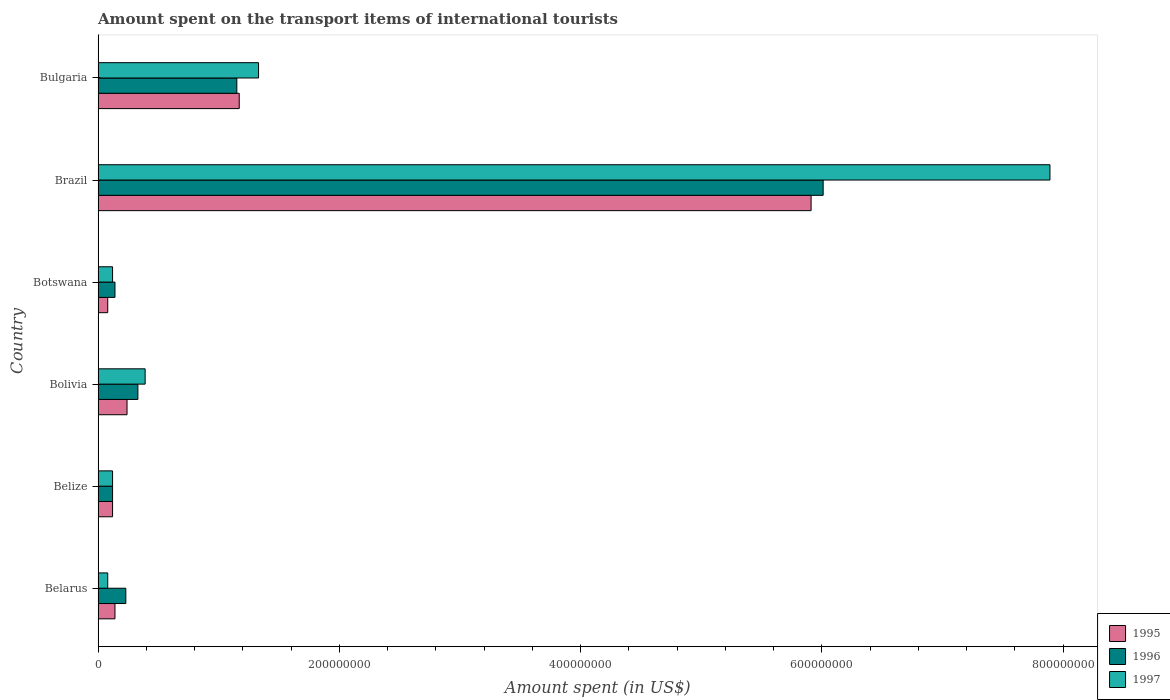How many groups of bars are there?
Your response must be concise. 6. Are the number of bars on each tick of the Y-axis equal?
Provide a short and direct response. Yes. In how many cases, is the number of bars for a given country not equal to the number of legend labels?
Offer a very short reply. 0. What is the amount spent on the transport items of international tourists in 1995 in Botswana?
Provide a succinct answer. 8.00e+06. Across all countries, what is the maximum amount spent on the transport items of international tourists in 1996?
Offer a very short reply. 6.01e+08. In which country was the amount spent on the transport items of international tourists in 1997 maximum?
Offer a terse response. Brazil. In which country was the amount spent on the transport items of international tourists in 1995 minimum?
Offer a very short reply. Botswana. What is the total amount spent on the transport items of international tourists in 1997 in the graph?
Ensure brevity in your answer.  9.93e+08. What is the difference between the amount spent on the transport items of international tourists in 1995 in Belarus and that in Bolivia?
Keep it short and to the point. -1.00e+07. What is the difference between the amount spent on the transport items of international tourists in 1995 in Bulgaria and the amount spent on the transport items of international tourists in 1996 in Botswana?
Ensure brevity in your answer.  1.03e+08. What is the average amount spent on the transport items of international tourists in 1995 per country?
Ensure brevity in your answer.  1.28e+08. What is the difference between the amount spent on the transport items of international tourists in 1997 and amount spent on the transport items of international tourists in 1995 in Bolivia?
Give a very brief answer. 1.50e+07. In how many countries, is the amount spent on the transport items of international tourists in 1995 greater than 320000000 US$?
Make the answer very short. 1. What is the ratio of the amount spent on the transport items of international tourists in 1997 in Botswana to that in Brazil?
Provide a short and direct response. 0.02. What is the difference between the highest and the second highest amount spent on the transport items of international tourists in 1997?
Your response must be concise. 6.56e+08. What is the difference between the highest and the lowest amount spent on the transport items of international tourists in 1995?
Give a very brief answer. 5.83e+08. In how many countries, is the amount spent on the transport items of international tourists in 1997 greater than the average amount spent on the transport items of international tourists in 1997 taken over all countries?
Ensure brevity in your answer.  1. What does the 2nd bar from the bottom in Bulgaria represents?
Give a very brief answer. 1996. Is it the case that in every country, the sum of the amount spent on the transport items of international tourists in 1995 and amount spent on the transport items of international tourists in 1996 is greater than the amount spent on the transport items of international tourists in 1997?
Offer a very short reply. Yes. How many bars are there?
Your answer should be very brief. 18. How many countries are there in the graph?
Make the answer very short. 6. Are the values on the major ticks of X-axis written in scientific E-notation?
Your answer should be very brief. No. Does the graph contain grids?
Ensure brevity in your answer.  No. How many legend labels are there?
Your response must be concise. 3. How are the legend labels stacked?
Your answer should be compact. Vertical. What is the title of the graph?
Ensure brevity in your answer.  Amount spent on the transport items of international tourists. What is the label or title of the X-axis?
Provide a succinct answer. Amount spent (in US$). What is the Amount spent (in US$) in 1995 in Belarus?
Offer a terse response. 1.40e+07. What is the Amount spent (in US$) of 1996 in Belarus?
Offer a very short reply. 2.30e+07. What is the Amount spent (in US$) in 1997 in Belize?
Provide a succinct answer. 1.20e+07. What is the Amount spent (in US$) in 1995 in Bolivia?
Your response must be concise. 2.40e+07. What is the Amount spent (in US$) in 1996 in Bolivia?
Give a very brief answer. 3.30e+07. What is the Amount spent (in US$) in 1997 in Bolivia?
Ensure brevity in your answer.  3.90e+07. What is the Amount spent (in US$) in 1995 in Botswana?
Provide a succinct answer. 8.00e+06. What is the Amount spent (in US$) in 1996 in Botswana?
Your response must be concise. 1.40e+07. What is the Amount spent (in US$) in 1995 in Brazil?
Make the answer very short. 5.91e+08. What is the Amount spent (in US$) of 1996 in Brazil?
Provide a succinct answer. 6.01e+08. What is the Amount spent (in US$) in 1997 in Brazil?
Offer a terse response. 7.89e+08. What is the Amount spent (in US$) in 1995 in Bulgaria?
Provide a short and direct response. 1.17e+08. What is the Amount spent (in US$) in 1996 in Bulgaria?
Provide a short and direct response. 1.15e+08. What is the Amount spent (in US$) of 1997 in Bulgaria?
Your answer should be compact. 1.33e+08. Across all countries, what is the maximum Amount spent (in US$) in 1995?
Ensure brevity in your answer.  5.91e+08. Across all countries, what is the maximum Amount spent (in US$) of 1996?
Provide a succinct answer. 6.01e+08. Across all countries, what is the maximum Amount spent (in US$) in 1997?
Offer a very short reply. 7.89e+08. Across all countries, what is the minimum Amount spent (in US$) of 1996?
Keep it short and to the point. 1.20e+07. Across all countries, what is the minimum Amount spent (in US$) of 1997?
Your answer should be compact. 8.00e+06. What is the total Amount spent (in US$) in 1995 in the graph?
Your answer should be very brief. 7.66e+08. What is the total Amount spent (in US$) of 1996 in the graph?
Ensure brevity in your answer.  7.98e+08. What is the total Amount spent (in US$) in 1997 in the graph?
Make the answer very short. 9.93e+08. What is the difference between the Amount spent (in US$) in 1996 in Belarus and that in Belize?
Your response must be concise. 1.10e+07. What is the difference between the Amount spent (in US$) of 1995 in Belarus and that in Bolivia?
Your answer should be compact. -1.00e+07. What is the difference between the Amount spent (in US$) of 1996 in Belarus and that in Bolivia?
Give a very brief answer. -1.00e+07. What is the difference between the Amount spent (in US$) of 1997 in Belarus and that in Bolivia?
Provide a short and direct response. -3.10e+07. What is the difference between the Amount spent (in US$) of 1996 in Belarus and that in Botswana?
Your response must be concise. 9.00e+06. What is the difference between the Amount spent (in US$) in 1997 in Belarus and that in Botswana?
Provide a succinct answer. -4.00e+06. What is the difference between the Amount spent (in US$) in 1995 in Belarus and that in Brazil?
Offer a very short reply. -5.77e+08. What is the difference between the Amount spent (in US$) of 1996 in Belarus and that in Brazil?
Keep it short and to the point. -5.78e+08. What is the difference between the Amount spent (in US$) in 1997 in Belarus and that in Brazil?
Offer a very short reply. -7.81e+08. What is the difference between the Amount spent (in US$) in 1995 in Belarus and that in Bulgaria?
Your answer should be compact. -1.03e+08. What is the difference between the Amount spent (in US$) in 1996 in Belarus and that in Bulgaria?
Make the answer very short. -9.20e+07. What is the difference between the Amount spent (in US$) of 1997 in Belarus and that in Bulgaria?
Make the answer very short. -1.25e+08. What is the difference between the Amount spent (in US$) of 1995 in Belize and that in Bolivia?
Provide a succinct answer. -1.20e+07. What is the difference between the Amount spent (in US$) of 1996 in Belize and that in Bolivia?
Offer a terse response. -2.10e+07. What is the difference between the Amount spent (in US$) in 1997 in Belize and that in Bolivia?
Give a very brief answer. -2.70e+07. What is the difference between the Amount spent (in US$) in 1995 in Belize and that in Brazil?
Keep it short and to the point. -5.79e+08. What is the difference between the Amount spent (in US$) in 1996 in Belize and that in Brazil?
Your answer should be very brief. -5.89e+08. What is the difference between the Amount spent (in US$) in 1997 in Belize and that in Brazil?
Ensure brevity in your answer.  -7.77e+08. What is the difference between the Amount spent (in US$) in 1995 in Belize and that in Bulgaria?
Provide a succinct answer. -1.05e+08. What is the difference between the Amount spent (in US$) in 1996 in Belize and that in Bulgaria?
Make the answer very short. -1.03e+08. What is the difference between the Amount spent (in US$) in 1997 in Belize and that in Bulgaria?
Your response must be concise. -1.21e+08. What is the difference between the Amount spent (in US$) in 1995 in Bolivia and that in Botswana?
Ensure brevity in your answer.  1.60e+07. What is the difference between the Amount spent (in US$) in 1996 in Bolivia and that in Botswana?
Make the answer very short. 1.90e+07. What is the difference between the Amount spent (in US$) in 1997 in Bolivia and that in Botswana?
Keep it short and to the point. 2.70e+07. What is the difference between the Amount spent (in US$) in 1995 in Bolivia and that in Brazil?
Give a very brief answer. -5.67e+08. What is the difference between the Amount spent (in US$) in 1996 in Bolivia and that in Brazil?
Offer a terse response. -5.68e+08. What is the difference between the Amount spent (in US$) of 1997 in Bolivia and that in Brazil?
Provide a short and direct response. -7.50e+08. What is the difference between the Amount spent (in US$) of 1995 in Bolivia and that in Bulgaria?
Offer a very short reply. -9.30e+07. What is the difference between the Amount spent (in US$) in 1996 in Bolivia and that in Bulgaria?
Give a very brief answer. -8.20e+07. What is the difference between the Amount spent (in US$) of 1997 in Bolivia and that in Bulgaria?
Provide a short and direct response. -9.40e+07. What is the difference between the Amount spent (in US$) in 1995 in Botswana and that in Brazil?
Provide a succinct answer. -5.83e+08. What is the difference between the Amount spent (in US$) of 1996 in Botswana and that in Brazil?
Make the answer very short. -5.87e+08. What is the difference between the Amount spent (in US$) of 1997 in Botswana and that in Brazil?
Provide a succinct answer. -7.77e+08. What is the difference between the Amount spent (in US$) of 1995 in Botswana and that in Bulgaria?
Give a very brief answer. -1.09e+08. What is the difference between the Amount spent (in US$) in 1996 in Botswana and that in Bulgaria?
Offer a terse response. -1.01e+08. What is the difference between the Amount spent (in US$) in 1997 in Botswana and that in Bulgaria?
Ensure brevity in your answer.  -1.21e+08. What is the difference between the Amount spent (in US$) of 1995 in Brazil and that in Bulgaria?
Offer a very short reply. 4.74e+08. What is the difference between the Amount spent (in US$) in 1996 in Brazil and that in Bulgaria?
Your response must be concise. 4.86e+08. What is the difference between the Amount spent (in US$) of 1997 in Brazil and that in Bulgaria?
Your answer should be compact. 6.56e+08. What is the difference between the Amount spent (in US$) in 1996 in Belarus and the Amount spent (in US$) in 1997 in Belize?
Offer a very short reply. 1.10e+07. What is the difference between the Amount spent (in US$) in 1995 in Belarus and the Amount spent (in US$) in 1996 in Bolivia?
Offer a terse response. -1.90e+07. What is the difference between the Amount spent (in US$) in 1995 in Belarus and the Amount spent (in US$) in 1997 in Bolivia?
Make the answer very short. -2.50e+07. What is the difference between the Amount spent (in US$) in 1996 in Belarus and the Amount spent (in US$) in 1997 in Bolivia?
Your answer should be compact. -1.60e+07. What is the difference between the Amount spent (in US$) of 1995 in Belarus and the Amount spent (in US$) of 1996 in Botswana?
Provide a short and direct response. 0. What is the difference between the Amount spent (in US$) of 1995 in Belarus and the Amount spent (in US$) of 1997 in Botswana?
Give a very brief answer. 2.00e+06. What is the difference between the Amount spent (in US$) in 1996 in Belarus and the Amount spent (in US$) in 1997 in Botswana?
Keep it short and to the point. 1.10e+07. What is the difference between the Amount spent (in US$) of 1995 in Belarus and the Amount spent (in US$) of 1996 in Brazil?
Give a very brief answer. -5.87e+08. What is the difference between the Amount spent (in US$) in 1995 in Belarus and the Amount spent (in US$) in 1997 in Brazil?
Offer a terse response. -7.75e+08. What is the difference between the Amount spent (in US$) in 1996 in Belarus and the Amount spent (in US$) in 1997 in Brazil?
Your answer should be very brief. -7.66e+08. What is the difference between the Amount spent (in US$) in 1995 in Belarus and the Amount spent (in US$) in 1996 in Bulgaria?
Your answer should be compact. -1.01e+08. What is the difference between the Amount spent (in US$) of 1995 in Belarus and the Amount spent (in US$) of 1997 in Bulgaria?
Offer a terse response. -1.19e+08. What is the difference between the Amount spent (in US$) of 1996 in Belarus and the Amount spent (in US$) of 1997 in Bulgaria?
Make the answer very short. -1.10e+08. What is the difference between the Amount spent (in US$) of 1995 in Belize and the Amount spent (in US$) of 1996 in Bolivia?
Ensure brevity in your answer.  -2.10e+07. What is the difference between the Amount spent (in US$) of 1995 in Belize and the Amount spent (in US$) of 1997 in Bolivia?
Your answer should be compact. -2.70e+07. What is the difference between the Amount spent (in US$) of 1996 in Belize and the Amount spent (in US$) of 1997 in Bolivia?
Provide a short and direct response. -2.70e+07. What is the difference between the Amount spent (in US$) of 1995 in Belize and the Amount spent (in US$) of 1997 in Botswana?
Provide a succinct answer. 0. What is the difference between the Amount spent (in US$) in 1996 in Belize and the Amount spent (in US$) in 1997 in Botswana?
Offer a terse response. 0. What is the difference between the Amount spent (in US$) of 1995 in Belize and the Amount spent (in US$) of 1996 in Brazil?
Make the answer very short. -5.89e+08. What is the difference between the Amount spent (in US$) of 1995 in Belize and the Amount spent (in US$) of 1997 in Brazil?
Make the answer very short. -7.77e+08. What is the difference between the Amount spent (in US$) in 1996 in Belize and the Amount spent (in US$) in 1997 in Brazil?
Keep it short and to the point. -7.77e+08. What is the difference between the Amount spent (in US$) of 1995 in Belize and the Amount spent (in US$) of 1996 in Bulgaria?
Your response must be concise. -1.03e+08. What is the difference between the Amount spent (in US$) in 1995 in Belize and the Amount spent (in US$) in 1997 in Bulgaria?
Offer a very short reply. -1.21e+08. What is the difference between the Amount spent (in US$) in 1996 in Belize and the Amount spent (in US$) in 1997 in Bulgaria?
Provide a short and direct response. -1.21e+08. What is the difference between the Amount spent (in US$) in 1995 in Bolivia and the Amount spent (in US$) in 1997 in Botswana?
Provide a succinct answer. 1.20e+07. What is the difference between the Amount spent (in US$) of 1996 in Bolivia and the Amount spent (in US$) of 1997 in Botswana?
Offer a very short reply. 2.10e+07. What is the difference between the Amount spent (in US$) in 1995 in Bolivia and the Amount spent (in US$) in 1996 in Brazil?
Ensure brevity in your answer.  -5.77e+08. What is the difference between the Amount spent (in US$) of 1995 in Bolivia and the Amount spent (in US$) of 1997 in Brazil?
Your response must be concise. -7.65e+08. What is the difference between the Amount spent (in US$) in 1996 in Bolivia and the Amount spent (in US$) in 1997 in Brazil?
Ensure brevity in your answer.  -7.56e+08. What is the difference between the Amount spent (in US$) of 1995 in Bolivia and the Amount spent (in US$) of 1996 in Bulgaria?
Make the answer very short. -9.10e+07. What is the difference between the Amount spent (in US$) of 1995 in Bolivia and the Amount spent (in US$) of 1997 in Bulgaria?
Offer a very short reply. -1.09e+08. What is the difference between the Amount spent (in US$) in 1996 in Bolivia and the Amount spent (in US$) in 1997 in Bulgaria?
Your answer should be very brief. -1.00e+08. What is the difference between the Amount spent (in US$) in 1995 in Botswana and the Amount spent (in US$) in 1996 in Brazil?
Your response must be concise. -5.93e+08. What is the difference between the Amount spent (in US$) of 1995 in Botswana and the Amount spent (in US$) of 1997 in Brazil?
Make the answer very short. -7.81e+08. What is the difference between the Amount spent (in US$) of 1996 in Botswana and the Amount spent (in US$) of 1997 in Brazil?
Give a very brief answer. -7.75e+08. What is the difference between the Amount spent (in US$) of 1995 in Botswana and the Amount spent (in US$) of 1996 in Bulgaria?
Make the answer very short. -1.07e+08. What is the difference between the Amount spent (in US$) in 1995 in Botswana and the Amount spent (in US$) in 1997 in Bulgaria?
Ensure brevity in your answer.  -1.25e+08. What is the difference between the Amount spent (in US$) of 1996 in Botswana and the Amount spent (in US$) of 1997 in Bulgaria?
Your answer should be very brief. -1.19e+08. What is the difference between the Amount spent (in US$) in 1995 in Brazil and the Amount spent (in US$) in 1996 in Bulgaria?
Ensure brevity in your answer.  4.76e+08. What is the difference between the Amount spent (in US$) of 1995 in Brazil and the Amount spent (in US$) of 1997 in Bulgaria?
Ensure brevity in your answer.  4.58e+08. What is the difference between the Amount spent (in US$) of 1996 in Brazil and the Amount spent (in US$) of 1997 in Bulgaria?
Make the answer very short. 4.68e+08. What is the average Amount spent (in US$) of 1995 per country?
Your answer should be compact. 1.28e+08. What is the average Amount spent (in US$) in 1996 per country?
Make the answer very short. 1.33e+08. What is the average Amount spent (in US$) of 1997 per country?
Your response must be concise. 1.66e+08. What is the difference between the Amount spent (in US$) of 1995 and Amount spent (in US$) of 1996 in Belarus?
Make the answer very short. -9.00e+06. What is the difference between the Amount spent (in US$) in 1995 and Amount spent (in US$) in 1997 in Belarus?
Your answer should be very brief. 6.00e+06. What is the difference between the Amount spent (in US$) of 1996 and Amount spent (in US$) of 1997 in Belarus?
Make the answer very short. 1.50e+07. What is the difference between the Amount spent (in US$) of 1995 and Amount spent (in US$) of 1996 in Belize?
Your answer should be very brief. 0. What is the difference between the Amount spent (in US$) of 1995 and Amount spent (in US$) of 1996 in Bolivia?
Give a very brief answer. -9.00e+06. What is the difference between the Amount spent (in US$) in 1995 and Amount spent (in US$) in 1997 in Bolivia?
Ensure brevity in your answer.  -1.50e+07. What is the difference between the Amount spent (in US$) in 1996 and Amount spent (in US$) in 1997 in Bolivia?
Provide a short and direct response. -6.00e+06. What is the difference between the Amount spent (in US$) of 1995 and Amount spent (in US$) of 1996 in Botswana?
Your response must be concise. -6.00e+06. What is the difference between the Amount spent (in US$) in 1995 and Amount spent (in US$) in 1997 in Botswana?
Your response must be concise. -4.00e+06. What is the difference between the Amount spent (in US$) of 1995 and Amount spent (in US$) of 1996 in Brazil?
Offer a terse response. -1.00e+07. What is the difference between the Amount spent (in US$) in 1995 and Amount spent (in US$) in 1997 in Brazil?
Offer a terse response. -1.98e+08. What is the difference between the Amount spent (in US$) of 1996 and Amount spent (in US$) of 1997 in Brazil?
Your answer should be compact. -1.88e+08. What is the difference between the Amount spent (in US$) of 1995 and Amount spent (in US$) of 1996 in Bulgaria?
Ensure brevity in your answer.  2.00e+06. What is the difference between the Amount spent (in US$) of 1995 and Amount spent (in US$) of 1997 in Bulgaria?
Offer a terse response. -1.60e+07. What is the difference between the Amount spent (in US$) of 1996 and Amount spent (in US$) of 1997 in Bulgaria?
Ensure brevity in your answer.  -1.80e+07. What is the ratio of the Amount spent (in US$) of 1995 in Belarus to that in Belize?
Your answer should be compact. 1.17. What is the ratio of the Amount spent (in US$) in 1996 in Belarus to that in Belize?
Provide a short and direct response. 1.92. What is the ratio of the Amount spent (in US$) in 1995 in Belarus to that in Bolivia?
Provide a succinct answer. 0.58. What is the ratio of the Amount spent (in US$) of 1996 in Belarus to that in Bolivia?
Provide a succinct answer. 0.7. What is the ratio of the Amount spent (in US$) in 1997 in Belarus to that in Bolivia?
Offer a terse response. 0.21. What is the ratio of the Amount spent (in US$) in 1996 in Belarus to that in Botswana?
Ensure brevity in your answer.  1.64. What is the ratio of the Amount spent (in US$) in 1997 in Belarus to that in Botswana?
Make the answer very short. 0.67. What is the ratio of the Amount spent (in US$) of 1995 in Belarus to that in Brazil?
Your response must be concise. 0.02. What is the ratio of the Amount spent (in US$) of 1996 in Belarus to that in Brazil?
Make the answer very short. 0.04. What is the ratio of the Amount spent (in US$) of 1997 in Belarus to that in Brazil?
Make the answer very short. 0.01. What is the ratio of the Amount spent (in US$) of 1995 in Belarus to that in Bulgaria?
Provide a succinct answer. 0.12. What is the ratio of the Amount spent (in US$) in 1996 in Belarus to that in Bulgaria?
Offer a very short reply. 0.2. What is the ratio of the Amount spent (in US$) in 1997 in Belarus to that in Bulgaria?
Make the answer very short. 0.06. What is the ratio of the Amount spent (in US$) of 1996 in Belize to that in Bolivia?
Offer a very short reply. 0.36. What is the ratio of the Amount spent (in US$) of 1997 in Belize to that in Bolivia?
Your answer should be compact. 0.31. What is the ratio of the Amount spent (in US$) in 1995 in Belize to that in Brazil?
Your answer should be very brief. 0.02. What is the ratio of the Amount spent (in US$) of 1996 in Belize to that in Brazil?
Your answer should be compact. 0.02. What is the ratio of the Amount spent (in US$) in 1997 in Belize to that in Brazil?
Give a very brief answer. 0.02. What is the ratio of the Amount spent (in US$) in 1995 in Belize to that in Bulgaria?
Give a very brief answer. 0.1. What is the ratio of the Amount spent (in US$) in 1996 in Belize to that in Bulgaria?
Make the answer very short. 0.1. What is the ratio of the Amount spent (in US$) of 1997 in Belize to that in Bulgaria?
Offer a very short reply. 0.09. What is the ratio of the Amount spent (in US$) in 1995 in Bolivia to that in Botswana?
Offer a very short reply. 3. What is the ratio of the Amount spent (in US$) of 1996 in Bolivia to that in Botswana?
Make the answer very short. 2.36. What is the ratio of the Amount spent (in US$) of 1995 in Bolivia to that in Brazil?
Offer a terse response. 0.04. What is the ratio of the Amount spent (in US$) in 1996 in Bolivia to that in Brazil?
Give a very brief answer. 0.05. What is the ratio of the Amount spent (in US$) of 1997 in Bolivia to that in Brazil?
Your answer should be very brief. 0.05. What is the ratio of the Amount spent (in US$) in 1995 in Bolivia to that in Bulgaria?
Your answer should be compact. 0.21. What is the ratio of the Amount spent (in US$) in 1996 in Bolivia to that in Bulgaria?
Give a very brief answer. 0.29. What is the ratio of the Amount spent (in US$) of 1997 in Bolivia to that in Bulgaria?
Offer a terse response. 0.29. What is the ratio of the Amount spent (in US$) in 1995 in Botswana to that in Brazil?
Offer a terse response. 0.01. What is the ratio of the Amount spent (in US$) of 1996 in Botswana to that in Brazil?
Your answer should be compact. 0.02. What is the ratio of the Amount spent (in US$) in 1997 in Botswana to that in Brazil?
Make the answer very short. 0.02. What is the ratio of the Amount spent (in US$) of 1995 in Botswana to that in Bulgaria?
Offer a terse response. 0.07. What is the ratio of the Amount spent (in US$) in 1996 in Botswana to that in Bulgaria?
Ensure brevity in your answer.  0.12. What is the ratio of the Amount spent (in US$) of 1997 in Botswana to that in Bulgaria?
Keep it short and to the point. 0.09. What is the ratio of the Amount spent (in US$) of 1995 in Brazil to that in Bulgaria?
Provide a succinct answer. 5.05. What is the ratio of the Amount spent (in US$) of 1996 in Brazil to that in Bulgaria?
Offer a terse response. 5.23. What is the ratio of the Amount spent (in US$) of 1997 in Brazil to that in Bulgaria?
Your answer should be compact. 5.93. What is the difference between the highest and the second highest Amount spent (in US$) of 1995?
Offer a very short reply. 4.74e+08. What is the difference between the highest and the second highest Amount spent (in US$) of 1996?
Provide a succinct answer. 4.86e+08. What is the difference between the highest and the second highest Amount spent (in US$) of 1997?
Your response must be concise. 6.56e+08. What is the difference between the highest and the lowest Amount spent (in US$) of 1995?
Provide a short and direct response. 5.83e+08. What is the difference between the highest and the lowest Amount spent (in US$) of 1996?
Your response must be concise. 5.89e+08. What is the difference between the highest and the lowest Amount spent (in US$) in 1997?
Provide a short and direct response. 7.81e+08. 